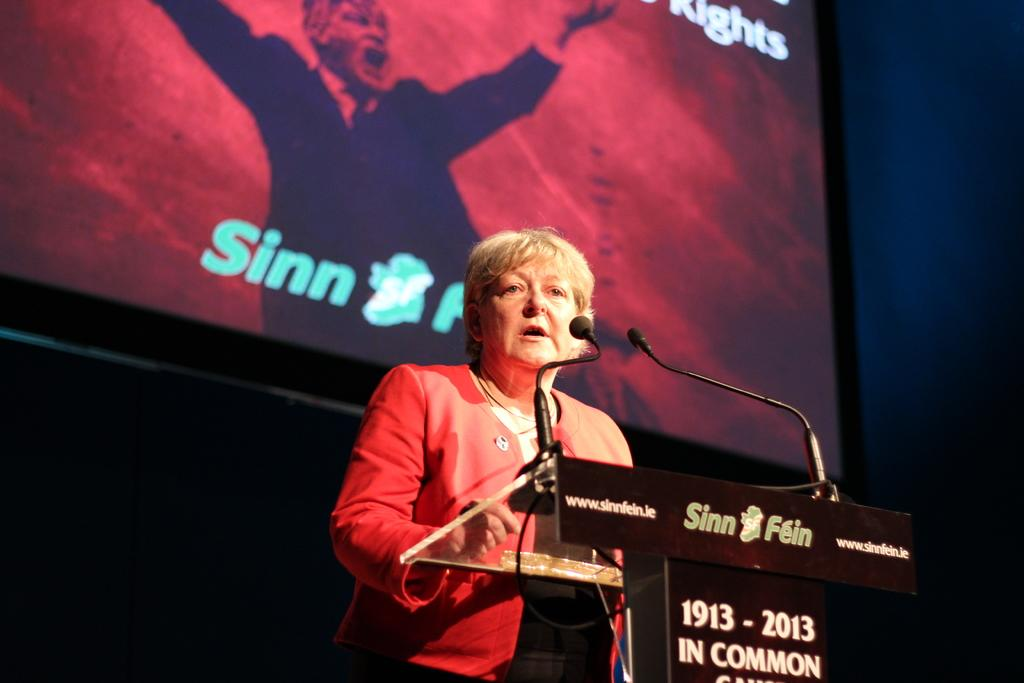<image>
Offer a succinct explanation of the picture presented. a lady is speaking at a podium with 1913 on it 